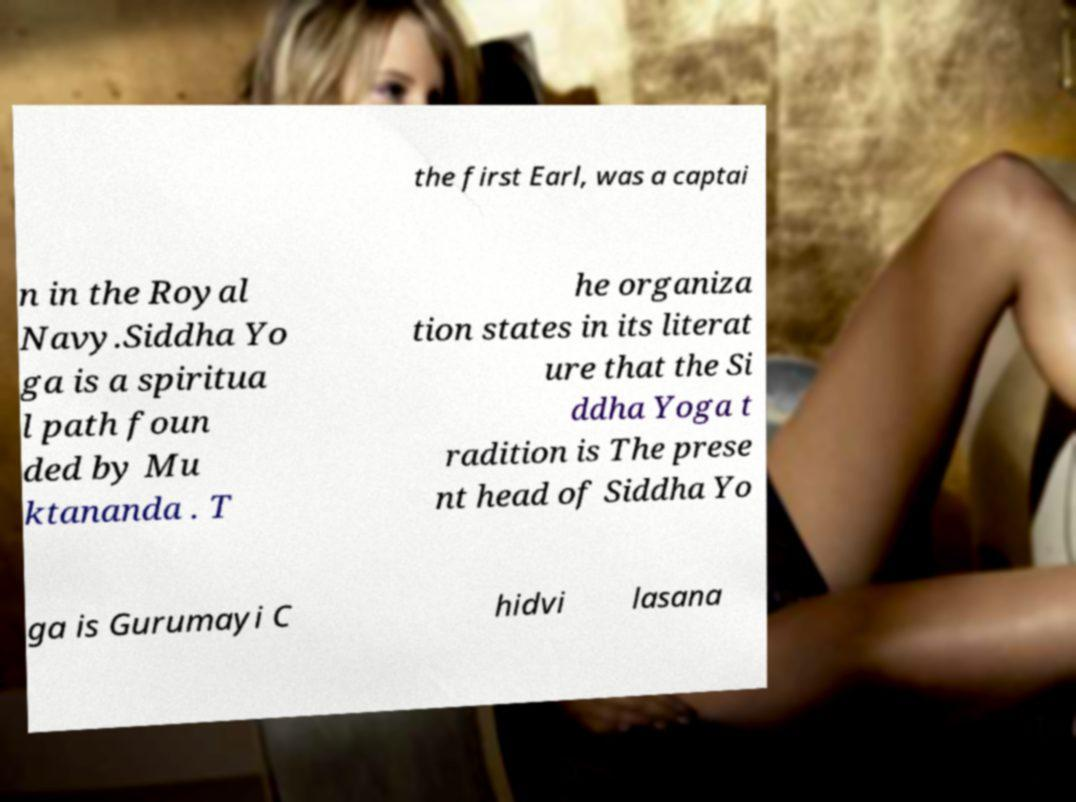Could you extract and type out the text from this image? the first Earl, was a captai n in the Royal Navy.Siddha Yo ga is a spiritua l path foun ded by Mu ktananda . T he organiza tion states in its literat ure that the Si ddha Yoga t radition is The prese nt head of Siddha Yo ga is Gurumayi C hidvi lasana 